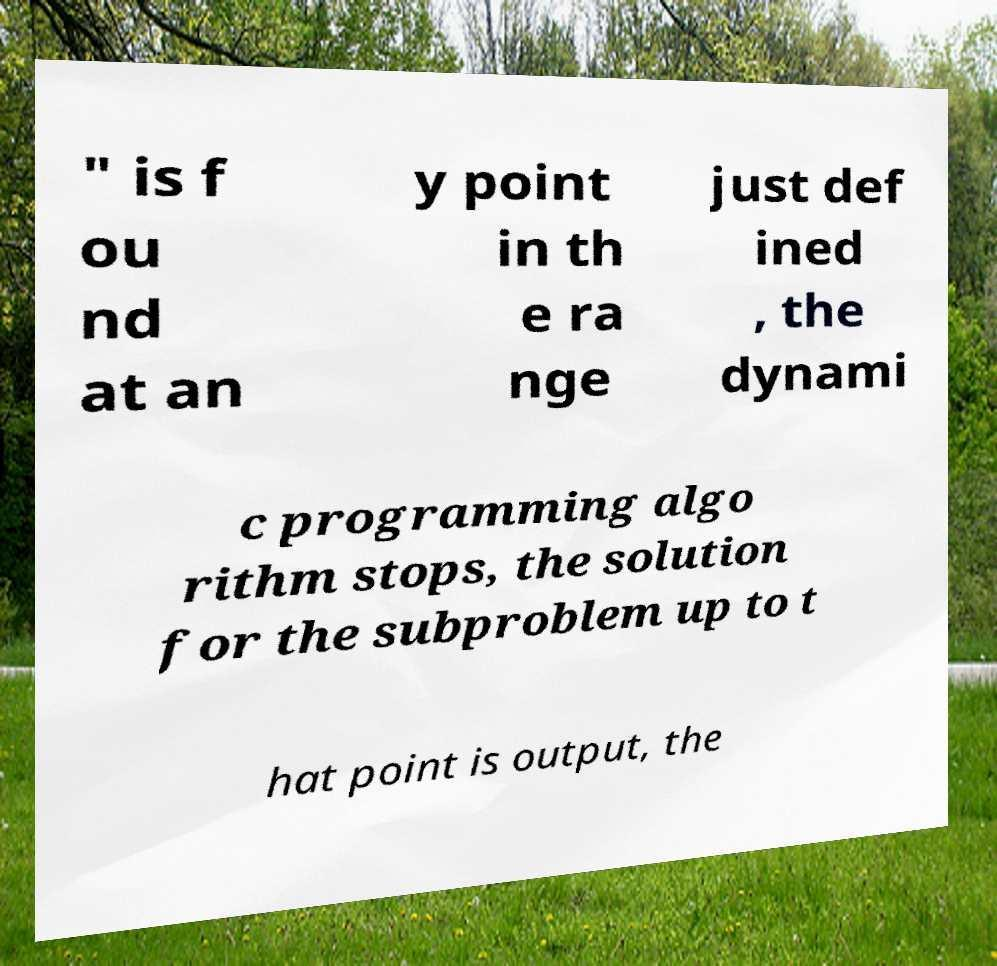Please identify and transcribe the text found in this image. " is f ou nd at an y point in th e ra nge just def ined , the dynami c programming algo rithm stops, the solution for the subproblem up to t hat point is output, the 